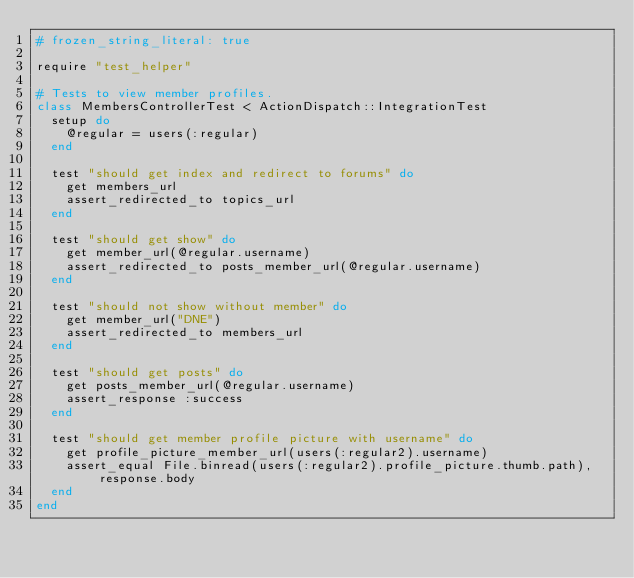<code> <loc_0><loc_0><loc_500><loc_500><_Ruby_># frozen_string_literal: true

require "test_helper"

# Tests to view member profiles.
class MembersControllerTest < ActionDispatch::IntegrationTest
  setup do
    @regular = users(:regular)
  end

  test "should get index and redirect to forums" do
    get members_url
    assert_redirected_to topics_url
  end

  test "should get show" do
    get member_url(@regular.username)
    assert_redirected_to posts_member_url(@regular.username)
  end

  test "should not show without member" do
    get member_url("DNE")
    assert_redirected_to members_url
  end

  test "should get posts" do
    get posts_member_url(@regular.username)
    assert_response :success
  end

  test "should get member profile picture with username" do
    get profile_picture_member_url(users(:regular2).username)
    assert_equal File.binread(users(:regular2).profile_picture.thumb.path), response.body
  end
end
</code> 